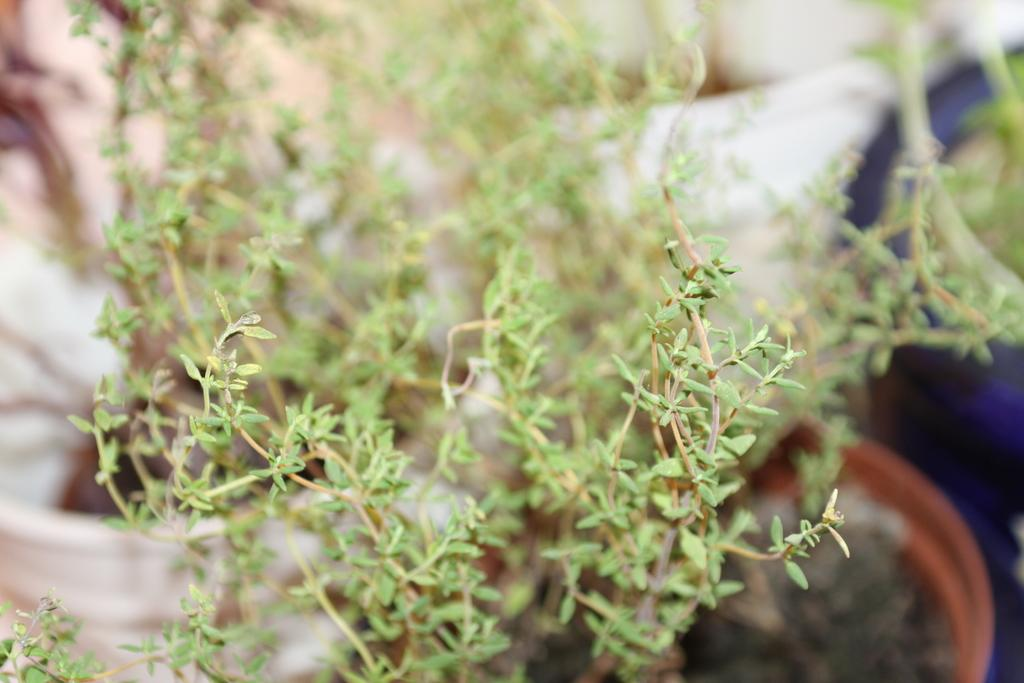What type of plant can be seen in the image? There is a green color plant in the image. What color is the plant pot that holds the plant? The plant pot is brown in color. Where is the plant pot located in the image? The plant pot is on the right side of the image. What can be seen in the background of the image? There are white color bags in the background of the image. What is the slope of the plant in the image? There is no slope present in the image, as it features a plant in a pot. 